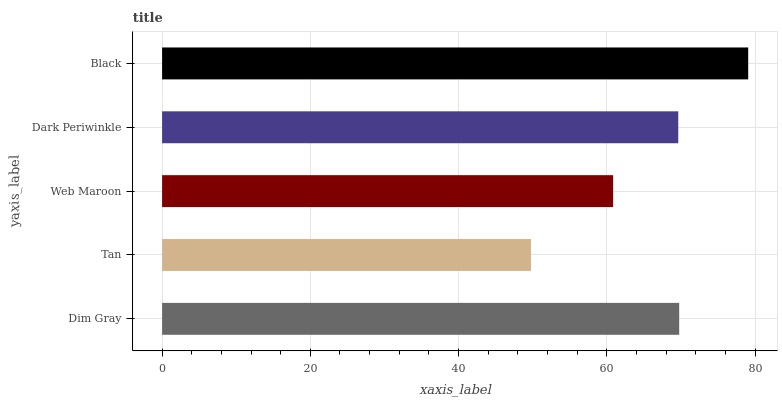Is Tan the minimum?
Answer yes or no. Yes. Is Black the maximum?
Answer yes or no. Yes. Is Web Maroon the minimum?
Answer yes or no. No. Is Web Maroon the maximum?
Answer yes or no. No. Is Web Maroon greater than Tan?
Answer yes or no. Yes. Is Tan less than Web Maroon?
Answer yes or no. Yes. Is Tan greater than Web Maroon?
Answer yes or no. No. Is Web Maroon less than Tan?
Answer yes or no. No. Is Dark Periwinkle the high median?
Answer yes or no. Yes. Is Dark Periwinkle the low median?
Answer yes or no. Yes. Is Web Maroon the high median?
Answer yes or no. No. Is Black the low median?
Answer yes or no. No. 